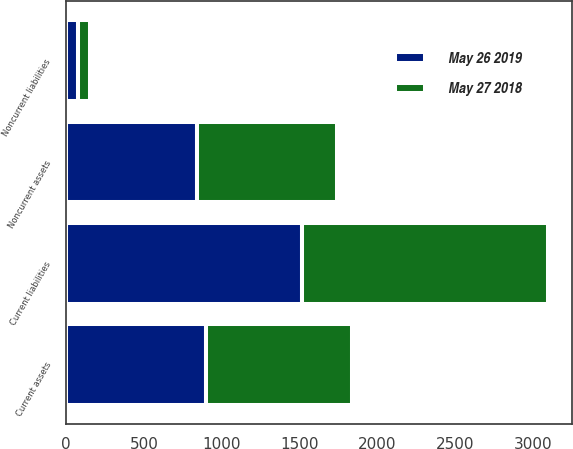<chart> <loc_0><loc_0><loc_500><loc_500><stacked_bar_chart><ecel><fcel>Current assets<fcel>Noncurrent assets<fcel>Current liabilities<fcel>Noncurrent liabilities<nl><fcel>May 26 2019<fcel>895.6<fcel>839.2<fcel>1517.3<fcel>77.1<nl><fcel>May 27 2018<fcel>938.5<fcel>902.5<fcel>1579.3<fcel>72.6<nl></chart> 